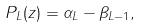<formula> <loc_0><loc_0><loc_500><loc_500>P _ { L } ( z ) = \alpha _ { L } - \beta _ { L - 1 } ,</formula> 